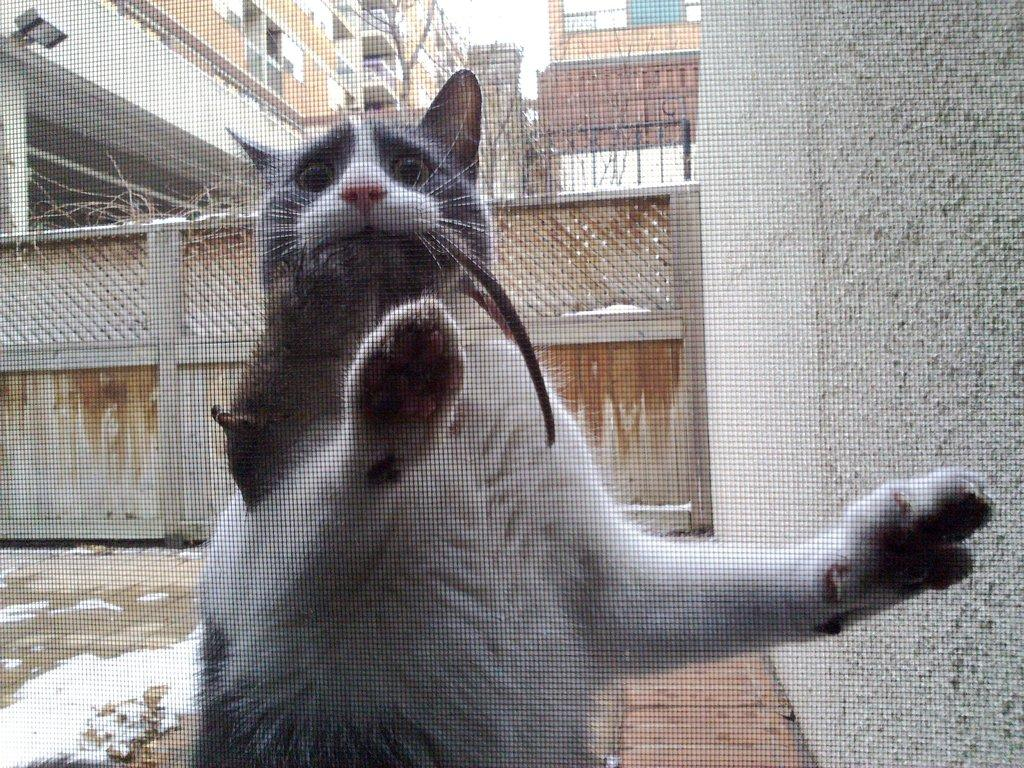What type of animal can be seen in the image? There is a cat in the image. What is visible in the background of the image? There is a gate and buildings in the background of the image. What is located on the right side of the image? There is a wall on the right side of the image. What type of berry is the cat holding in its ear in the image? There is no berry or any indication of the cat holding something in its ear in the image. 